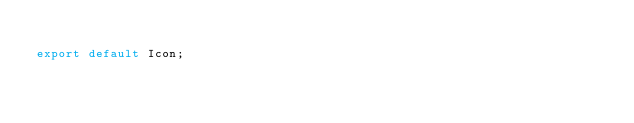<code> <loc_0><loc_0><loc_500><loc_500><_JavaScript_>
export default Icon;
</code> 